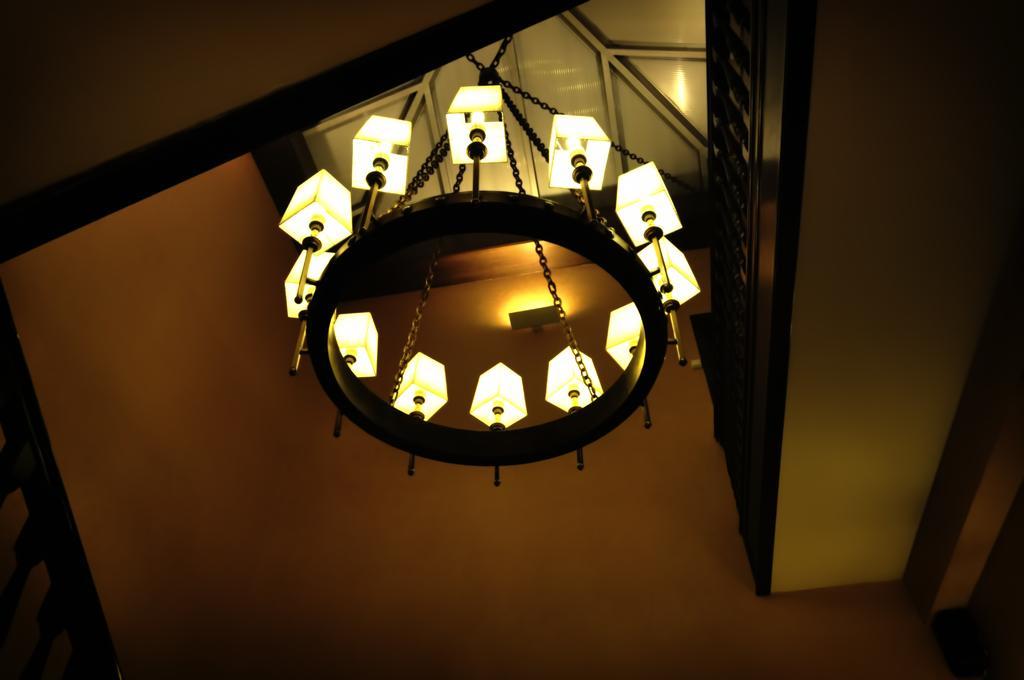Describe this image in one or two sentences. In this image I see the ceiling and I see the chandelier over here and I see the wall. 